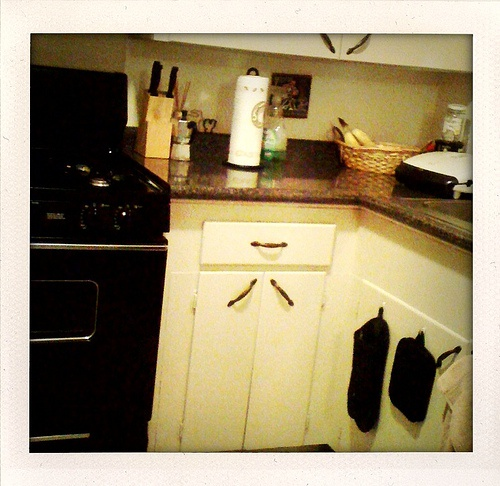Describe the objects in this image and their specific colors. I can see oven in lightgray, black, olive, white, and maroon tones, sink in lightgray, olive, maroon, and black tones, bottle in lightgray, tan, khaki, and olive tones, bottle in lightgray, olive, and tan tones, and banana in lightgray, khaki, and tan tones in this image. 